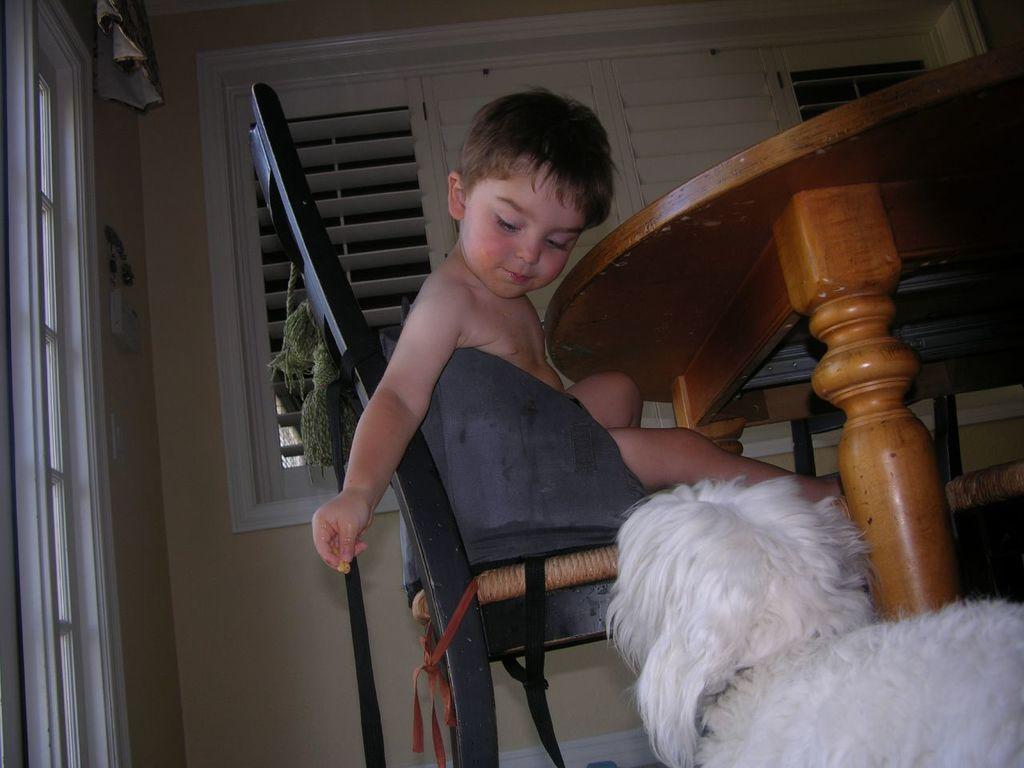What is the kid doing in the image? The kid is sitting on a chair in the image. Can you describe the animal in the image? There is an animal in the bottom right corner of the image. What is located beside the chair? There is a table beside the chair. What can be seen in the background of the image? There are windows in the background of the image. Where are the windows located? The windows are on a wall. What type of brick is the cactus sitting on in the image? There is no brick or cactus present in the image. 